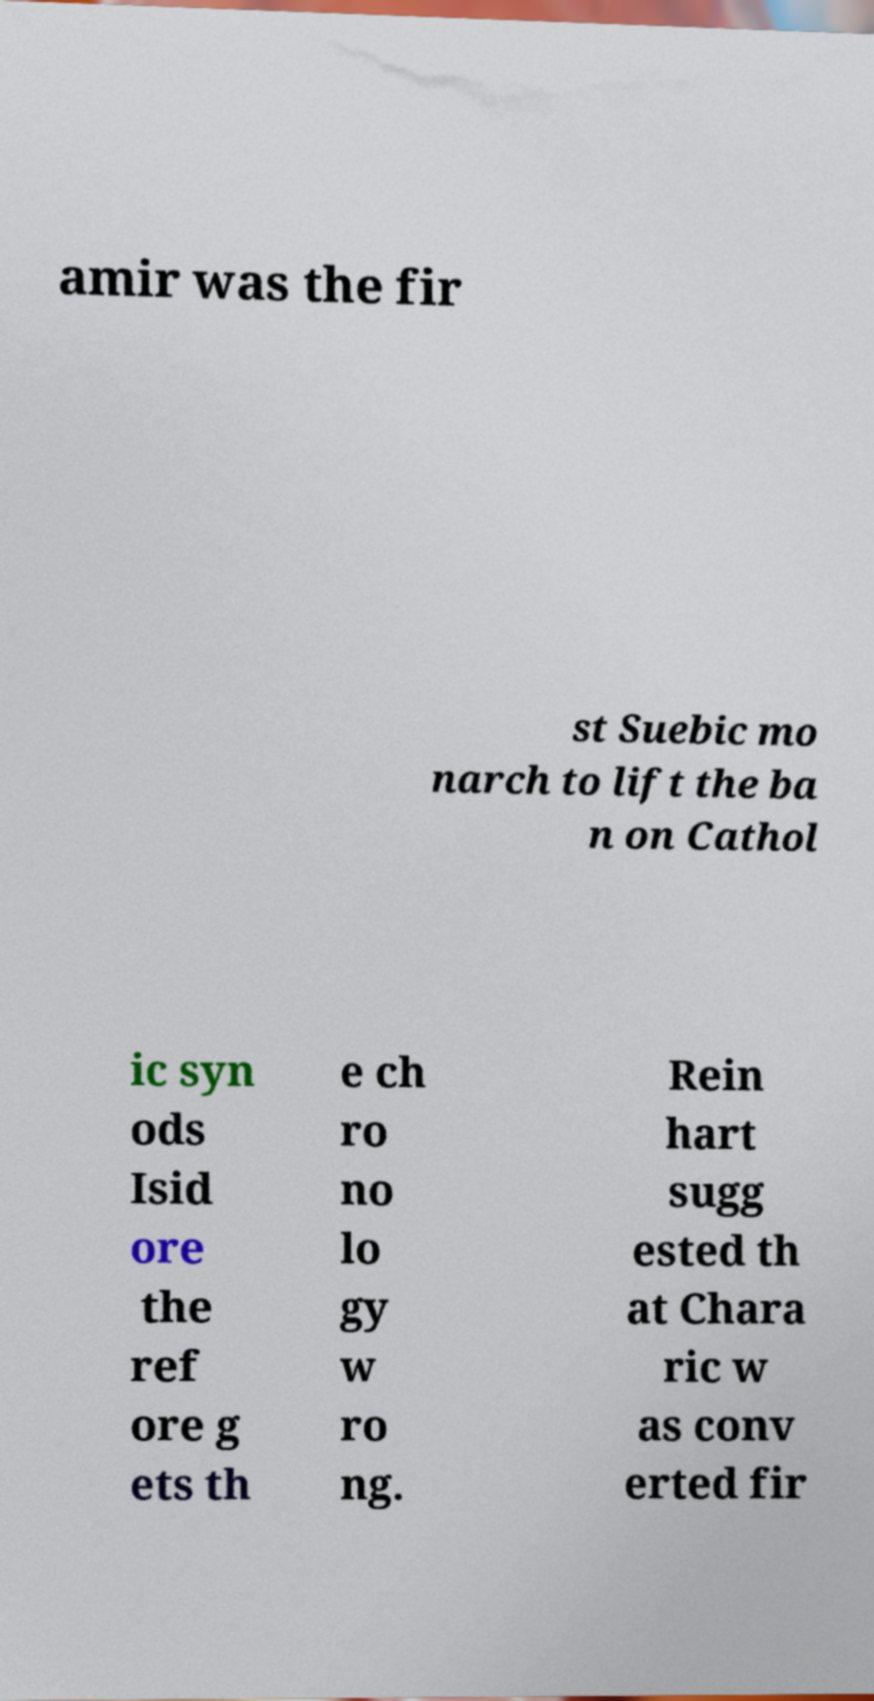For documentation purposes, I need the text within this image transcribed. Could you provide that? amir was the fir st Suebic mo narch to lift the ba n on Cathol ic syn ods Isid ore the ref ore g ets th e ch ro no lo gy w ro ng. Rein hart sugg ested th at Chara ric w as conv erted fir 